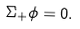<formula> <loc_0><loc_0><loc_500><loc_500>\Sigma _ { + } \phi = 0 .</formula> 